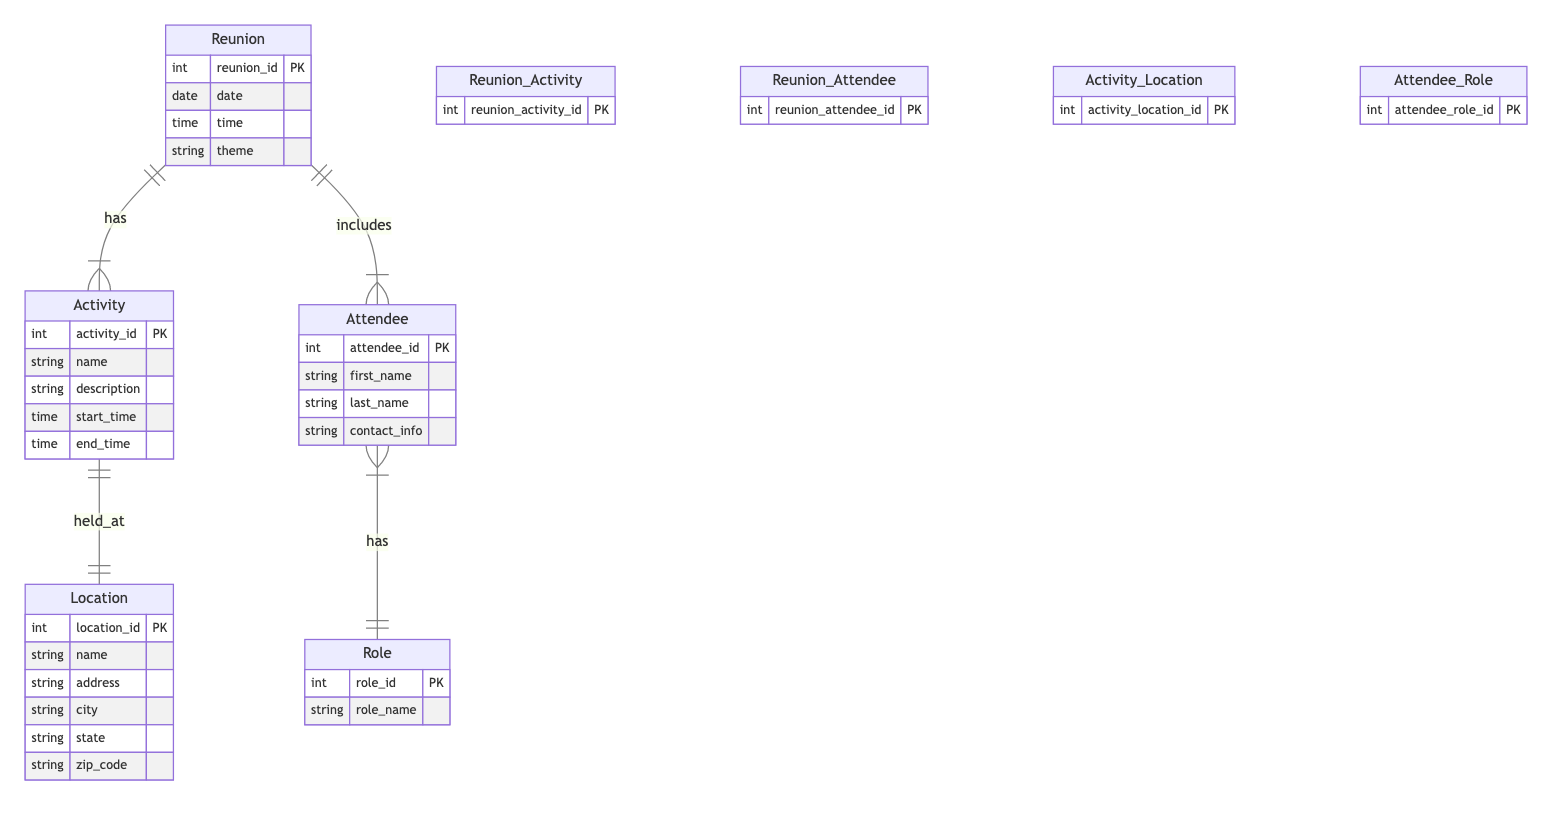What entities are involved in the Reunion Planning? The diagram shows five entities: Reunion, Activity, Attendee, Location, and Role, which are all involved in the reunion planning process for Alice.
Answer: Reunion, Activity, Attendee, Location, Role How many attributes does the Activity entity have? The Activity entity contains five attributes: activity_id, name, description, start_time, and end_time, indicating the details related to each activity.
Answer: 5 What is the relationship between Reunion and Attendee? The diagram indicates a '1 to many' relationship between Reunion and Attendee, meaning one reunion can include multiple attendees, but each attendee is associated with only one reunion.
Answer: 1 to many What is the primary key of the Location entity? The primary key of the Location entity is location_id, which uniquely identifies each location associated with the reunion activities.
Answer: location_id How many different roles can an attendee have? Since the relationship between Attendee and Role is 'many to 1', this indicates that multiple attendees can share the same role, but each attendee can only have one designated role. Therefore, the number of different roles depends on the data available in the Role entity. If only one role exists, then in this design, it would mean attendees can only have that one role equally.
Answer: many What is the relationship type between Activity and Location? The structure shows a '1 to 1' relationship between Activity and Location, indicating that each activity is held at exactly one location and each location can host only one activity at a given time.
Answer: 1 to 1 How can you identify which activity is scheduled at a particular location? By analyzing the Activity_Location relationship, you can use the activity_location_id to identify which activity is paired with a specific location. Each relationship entry connects a specific activity to a location through this identifier.
Answer: activity_location_id What is the purpose of the Reunion_Activity relationship? This relationship serves to link the Reunion entity with multiple Activity entities, indicating that a reunion can include several varied activities, organized together under the same event.
Answer: links Reunion to Activity 